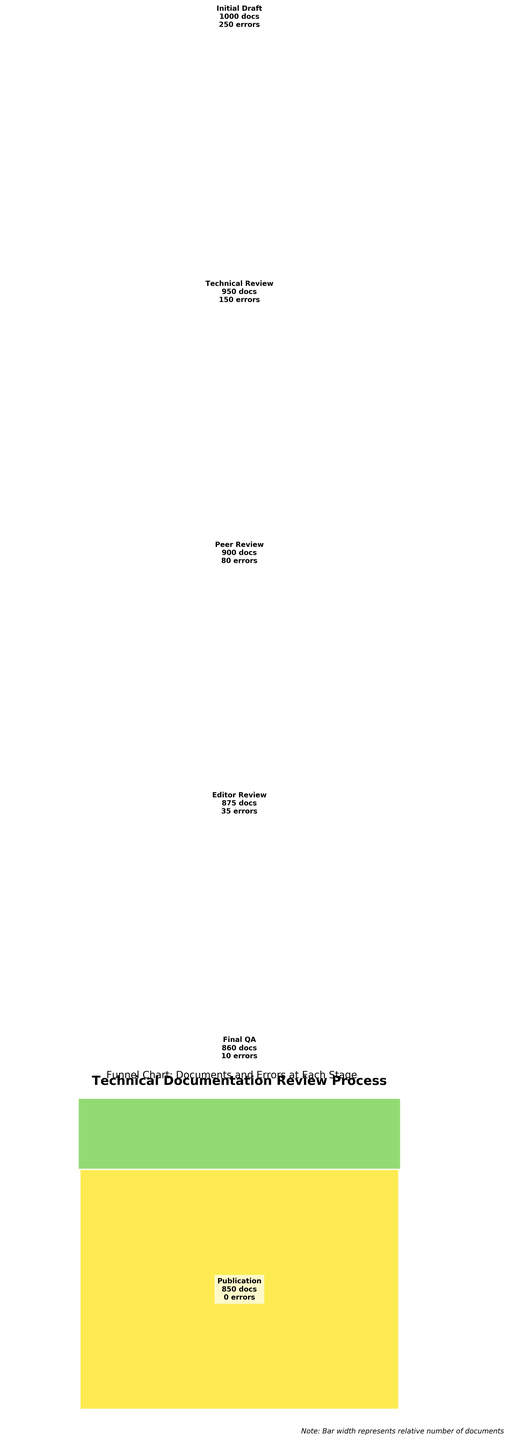What's the title of the funnel chart? The title is prominently displayed at the top of the chart.
Answer: Technical Documentation Review Process How many stages are there in the funnel chart? By counting the labeled sections (Initial Draft, Technical Review, Peer Review, Editor Review, Final QA, Publication) in the chart, we observe six stages.
Answer: 6 Which stage has the highest number of errors? Look at the number of errors listed next to each stage; the highest value is at the Initial Draft stage.
Answer: Initial Draft How many documents are left after the Technical Review stage? Check the number labeled next to the Technical Review stage. The label shows 950 documents.
Answer: 950 What is the percentage reduction in errors from the Initial Draft to the Technical Review stage? Initial Draft has 250 errors, and Technical Review has 150 errors. The percentage reduction is calculated as ((250 - 150) / 250) * 100.
Answer: 40% Which stage has the lowest number of errors, excluding the Publication stage? Aside from the Publication stage (which has 0 errors), the Final QA stage has the least errors, displaying 10 errors.
Answer: Final QA How many more errors are there in the Initial Draft stage compared to the Peer Review stage? Initial Draft has 250 errors, and Peer Review has 80 errors. The difference is calculated by subtracting 80 from 250.
Answer: 170 What is the total number of documents processed up to the Final QA stage? The number of documents is cumulative up to each stage. However, up to Final QA, the number remains at what is stated for Final QA: 860 documents.
Answer: 860 Is there any stage where the number of documents increases from one stage to the next? Review the number of documents at each successive stage and check for any increase. All numbers either stay the same or decrease, indicating no increase at any stage.
Answer: No What is the average number of errors across all stages excluding Publication? Sum the number of errors from Initial Draft (250), Technical Review (150), Peer Review (80), Editor Review (35), and Final QA (10), then divide by 5 stages. Average = (250+150+80+35+10)/5.
Answer: 105 